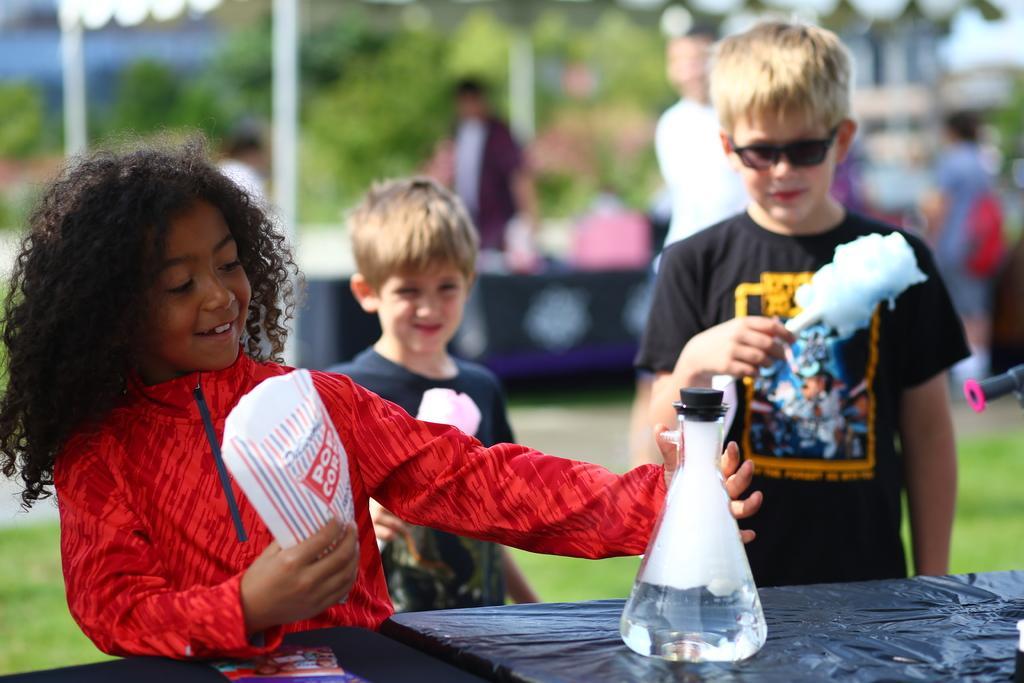How would you summarize this image in a sentence or two? In this image i can see a girl in red dress is standing and holding a beaker and a cover in both of her hands. In the background i can see 2 boys wearing black t shirts standing, the boy on the right side is holding an object in his hand and wearing glasses, i can see few other person's, a building, few trees and a tent in the background. 